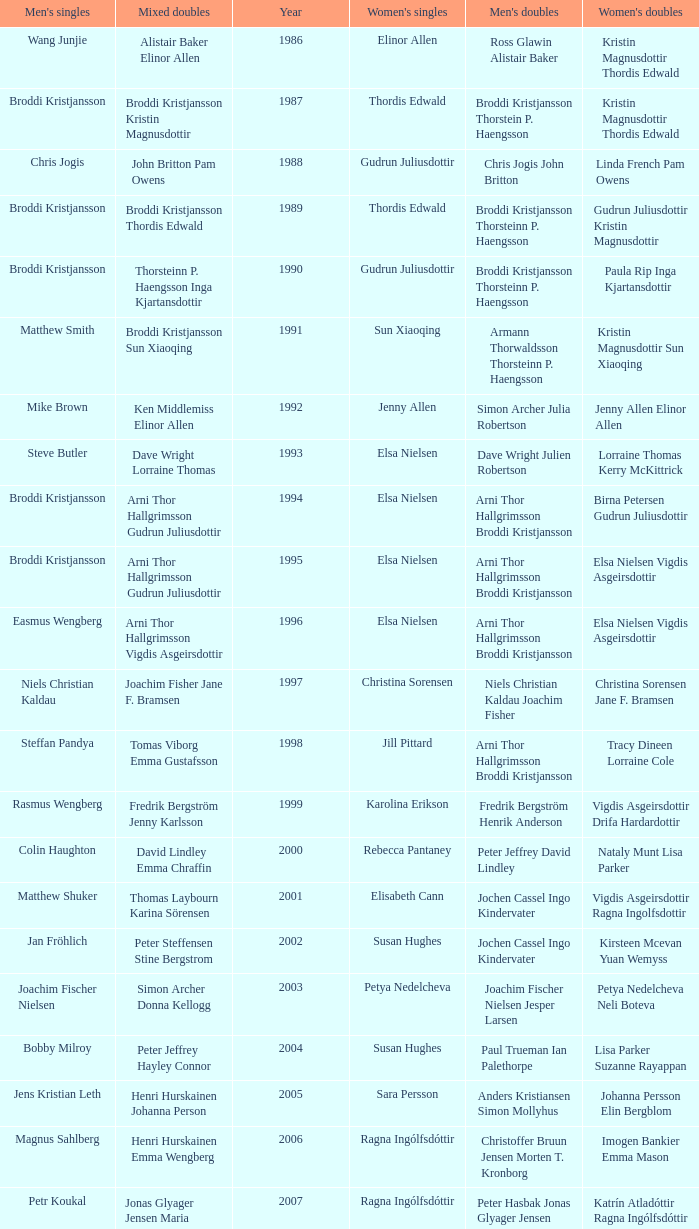Which mixed doubles happened later than 2011? Chou Tien-chen Chiang Mei-hui. 